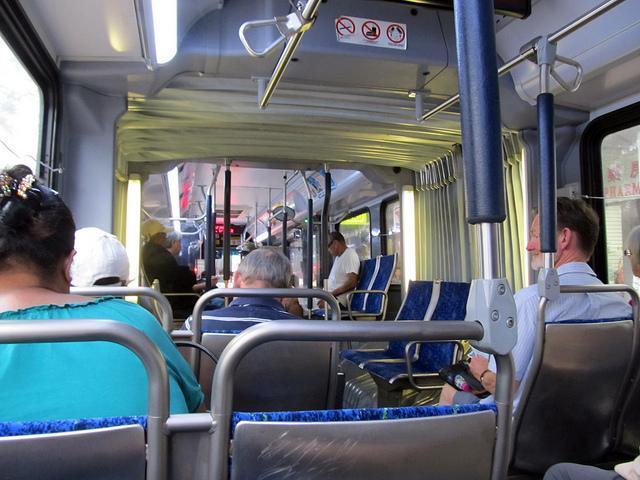How many people are in the picture?
Give a very brief answer. 5. How many chairs can be seen?
Give a very brief answer. 4. 